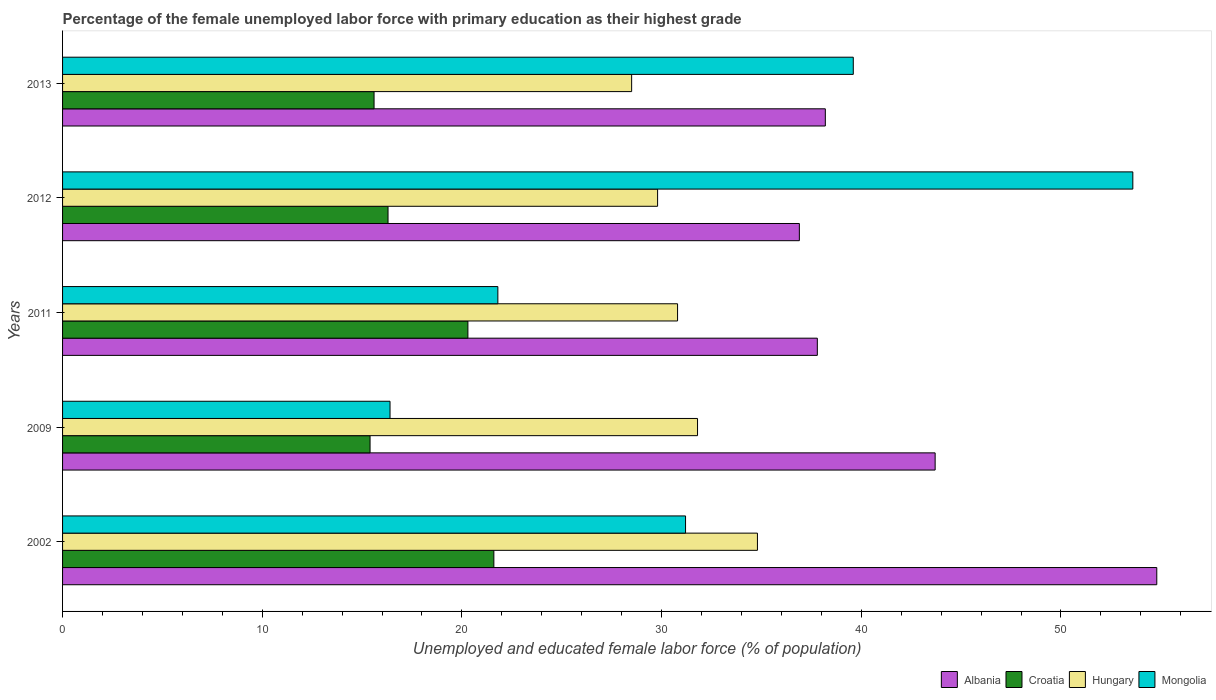How many different coloured bars are there?
Give a very brief answer. 4. Are the number of bars per tick equal to the number of legend labels?
Offer a terse response. Yes. Are the number of bars on each tick of the Y-axis equal?
Give a very brief answer. Yes. What is the percentage of the unemployed female labor force with primary education in Albania in 2013?
Offer a very short reply. 38.2. Across all years, what is the maximum percentage of the unemployed female labor force with primary education in Hungary?
Your answer should be very brief. 34.8. Across all years, what is the minimum percentage of the unemployed female labor force with primary education in Croatia?
Provide a succinct answer. 15.4. In which year was the percentage of the unemployed female labor force with primary education in Hungary maximum?
Offer a terse response. 2002. What is the total percentage of the unemployed female labor force with primary education in Croatia in the graph?
Your answer should be very brief. 89.2. What is the difference between the percentage of the unemployed female labor force with primary education in Albania in 2009 and that in 2012?
Your answer should be very brief. 6.8. What is the difference between the percentage of the unemployed female labor force with primary education in Albania in 2013 and the percentage of the unemployed female labor force with primary education in Croatia in 2012?
Ensure brevity in your answer.  21.9. What is the average percentage of the unemployed female labor force with primary education in Albania per year?
Ensure brevity in your answer.  42.28. In the year 2013, what is the difference between the percentage of the unemployed female labor force with primary education in Albania and percentage of the unemployed female labor force with primary education in Hungary?
Your response must be concise. 9.7. What is the ratio of the percentage of the unemployed female labor force with primary education in Hungary in 2011 to that in 2013?
Provide a succinct answer. 1.08. What is the difference between the highest and the second highest percentage of the unemployed female labor force with primary education in Croatia?
Offer a terse response. 1.3. What is the difference between the highest and the lowest percentage of the unemployed female labor force with primary education in Albania?
Your answer should be very brief. 17.9. What does the 4th bar from the top in 2013 represents?
Your answer should be very brief. Albania. What does the 2nd bar from the bottom in 2009 represents?
Offer a very short reply. Croatia. Is it the case that in every year, the sum of the percentage of the unemployed female labor force with primary education in Croatia and percentage of the unemployed female labor force with primary education in Mongolia is greater than the percentage of the unemployed female labor force with primary education in Hungary?
Give a very brief answer. Yes. How many bars are there?
Provide a short and direct response. 20. Are all the bars in the graph horizontal?
Your answer should be compact. Yes. How many years are there in the graph?
Provide a short and direct response. 5. Does the graph contain grids?
Provide a succinct answer. No. How many legend labels are there?
Your answer should be very brief. 4. What is the title of the graph?
Your answer should be very brief. Percentage of the female unemployed labor force with primary education as their highest grade. Does "Sierra Leone" appear as one of the legend labels in the graph?
Provide a succinct answer. No. What is the label or title of the X-axis?
Provide a short and direct response. Unemployed and educated female labor force (% of population). What is the label or title of the Y-axis?
Your response must be concise. Years. What is the Unemployed and educated female labor force (% of population) of Albania in 2002?
Provide a succinct answer. 54.8. What is the Unemployed and educated female labor force (% of population) of Croatia in 2002?
Your answer should be compact. 21.6. What is the Unemployed and educated female labor force (% of population) of Hungary in 2002?
Keep it short and to the point. 34.8. What is the Unemployed and educated female labor force (% of population) of Mongolia in 2002?
Provide a short and direct response. 31.2. What is the Unemployed and educated female labor force (% of population) of Albania in 2009?
Your response must be concise. 43.7. What is the Unemployed and educated female labor force (% of population) of Croatia in 2009?
Make the answer very short. 15.4. What is the Unemployed and educated female labor force (% of population) in Hungary in 2009?
Provide a succinct answer. 31.8. What is the Unemployed and educated female labor force (% of population) of Mongolia in 2009?
Offer a very short reply. 16.4. What is the Unemployed and educated female labor force (% of population) of Albania in 2011?
Your answer should be compact. 37.8. What is the Unemployed and educated female labor force (% of population) of Croatia in 2011?
Your answer should be compact. 20.3. What is the Unemployed and educated female labor force (% of population) in Hungary in 2011?
Your answer should be compact. 30.8. What is the Unemployed and educated female labor force (% of population) of Mongolia in 2011?
Ensure brevity in your answer.  21.8. What is the Unemployed and educated female labor force (% of population) of Albania in 2012?
Provide a short and direct response. 36.9. What is the Unemployed and educated female labor force (% of population) in Croatia in 2012?
Provide a short and direct response. 16.3. What is the Unemployed and educated female labor force (% of population) in Hungary in 2012?
Your answer should be compact. 29.8. What is the Unemployed and educated female labor force (% of population) in Mongolia in 2012?
Ensure brevity in your answer.  53.6. What is the Unemployed and educated female labor force (% of population) of Albania in 2013?
Offer a very short reply. 38.2. What is the Unemployed and educated female labor force (% of population) in Croatia in 2013?
Your answer should be very brief. 15.6. What is the Unemployed and educated female labor force (% of population) in Hungary in 2013?
Give a very brief answer. 28.5. What is the Unemployed and educated female labor force (% of population) in Mongolia in 2013?
Make the answer very short. 39.6. Across all years, what is the maximum Unemployed and educated female labor force (% of population) of Albania?
Provide a short and direct response. 54.8. Across all years, what is the maximum Unemployed and educated female labor force (% of population) of Croatia?
Offer a terse response. 21.6. Across all years, what is the maximum Unemployed and educated female labor force (% of population) in Hungary?
Your answer should be very brief. 34.8. Across all years, what is the maximum Unemployed and educated female labor force (% of population) of Mongolia?
Provide a short and direct response. 53.6. Across all years, what is the minimum Unemployed and educated female labor force (% of population) of Albania?
Offer a very short reply. 36.9. Across all years, what is the minimum Unemployed and educated female labor force (% of population) of Croatia?
Your answer should be compact. 15.4. Across all years, what is the minimum Unemployed and educated female labor force (% of population) in Hungary?
Make the answer very short. 28.5. Across all years, what is the minimum Unemployed and educated female labor force (% of population) in Mongolia?
Your answer should be very brief. 16.4. What is the total Unemployed and educated female labor force (% of population) of Albania in the graph?
Your answer should be compact. 211.4. What is the total Unemployed and educated female labor force (% of population) of Croatia in the graph?
Offer a terse response. 89.2. What is the total Unemployed and educated female labor force (% of population) in Hungary in the graph?
Your answer should be very brief. 155.7. What is the total Unemployed and educated female labor force (% of population) in Mongolia in the graph?
Offer a terse response. 162.6. What is the difference between the Unemployed and educated female labor force (% of population) in Albania in 2002 and that in 2009?
Keep it short and to the point. 11.1. What is the difference between the Unemployed and educated female labor force (% of population) in Hungary in 2002 and that in 2009?
Keep it short and to the point. 3. What is the difference between the Unemployed and educated female labor force (% of population) in Mongolia in 2002 and that in 2009?
Keep it short and to the point. 14.8. What is the difference between the Unemployed and educated female labor force (% of population) of Croatia in 2002 and that in 2011?
Offer a very short reply. 1.3. What is the difference between the Unemployed and educated female labor force (% of population) of Mongolia in 2002 and that in 2011?
Keep it short and to the point. 9.4. What is the difference between the Unemployed and educated female labor force (% of population) in Albania in 2002 and that in 2012?
Your response must be concise. 17.9. What is the difference between the Unemployed and educated female labor force (% of population) of Croatia in 2002 and that in 2012?
Make the answer very short. 5.3. What is the difference between the Unemployed and educated female labor force (% of population) of Hungary in 2002 and that in 2012?
Ensure brevity in your answer.  5. What is the difference between the Unemployed and educated female labor force (% of population) of Mongolia in 2002 and that in 2012?
Ensure brevity in your answer.  -22.4. What is the difference between the Unemployed and educated female labor force (% of population) of Hungary in 2002 and that in 2013?
Offer a very short reply. 6.3. What is the difference between the Unemployed and educated female labor force (% of population) of Mongolia in 2002 and that in 2013?
Your answer should be very brief. -8.4. What is the difference between the Unemployed and educated female labor force (% of population) of Croatia in 2009 and that in 2011?
Your answer should be very brief. -4.9. What is the difference between the Unemployed and educated female labor force (% of population) in Hungary in 2009 and that in 2011?
Provide a succinct answer. 1. What is the difference between the Unemployed and educated female labor force (% of population) of Mongolia in 2009 and that in 2011?
Your response must be concise. -5.4. What is the difference between the Unemployed and educated female labor force (% of population) in Mongolia in 2009 and that in 2012?
Your response must be concise. -37.2. What is the difference between the Unemployed and educated female labor force (% of population) of Albania in 2009 and that in 2013?
Ensure brevity in your answer.  5.5. What is the difference between the Unemployed and educated female labor force (% of population) in Croatia in 2009 and that in 2013?
Offer a terse response. -0.2. What is the difference between the Unemployed and educated female labor force (% of population) in Hungary in 2009 and that in 2013?
Keep it short and to the point. 3.3. What is the difference between the Unemployed and educated female labor force (% of population) of Mongolia in 2009 and that in 2013?
Make the answer very short. -23.2. What is the difference between the Unemployed and educated female labor force (% of population) of Croatia in 2011 and that in 2012?
Give a very brief answer. 4. What is the difference between the Unemployed and educated female labor force (% of population) in Hungary in 2011 and that in 2012?
Provide a short and direct response. 1. What is the difference between the Unemployed and educated female labor force (% of population) of Mongolia in 2011 and that in 2012?
Ensure brevity in your answer.  -31.8. What is the difference between the Unemployed and educated female labor force (% of population) of Hungary in 2011 and that in 2013?
Your answer should be very brief. 2.3. What is the difference between the Unemployed and educated female labor force (% of population) of Mongolia in 2011 and that in 2013?
Keep it short and to the point. -17.8. What is the difference between the Unemployed and educated female labor force (% of population) in Hungary in 2012 and that in 2013?
Keep it short and to the point. 1.3. What is the difference between the Unemployed and educated female labor force (% of population) of Mongolia in 2012 and that in 2013?
Keep it short and to the point. 14. What is the difference between the Unemployed and educated female labor force (% of population) in Albania in 2002 and the Unemployed and educated female labor force (% of population) in Croatia in 2009?
Offer a very short reply. 39.4. What is the difference between the Unemployed and educated female labor force (% of population) of Albania in 2002 and the Unemployed and educated female labor force (% of population) of Mongolia in 2009?
Your response must be concise. 38.4. What is the difference between the Unemployed and educated female labor force (% of population) of Croatia in 2002 and the Unemployed and educated female labor force (% of population) of Hungary in 2009?
Your response must be concise. -10.2. What is the difference between the Unemployed and educated female labor force (% of population) in Albania in 2002 and the Unemployed and educated female labor force (% of population) in Croatia in 2011?
Your answer should be compact. 34.5. What is the difference between the Unemployed and educated female labor force (% of population) in Albania in 2002 and the Unemployed and educated female labor force (% of population) in Hungary in 2011?
Make the answer very short. 24. What is the difference between the Unemployed and educated female labor force (% of population) of Croatia in 2002 and the Unemployed and educated female labor force (% of population) of Hungary in 2011?
Your answer should be compact. -9.2. What is the difference between the Unemployed and educated female labor force (% of population) of Croatia in 2002 and the Unemployed and educated female labor force (% of population) of Mongolia in 2011?
Your answer should be compact. -0.2. What is the difference between the Unemployed and educated female labor force (% of population) of Albania in 2002 and the Unemployed and educated female labor force (% of population) of Croatia in 2012?
Provide a succinct answer. 38.5. What is the difference between the Unemployed and educated female labor force (% of population) of Croatia in 2002 and the Unemployed and educated female labor force (% of population) of Hungary in 2012?
Ensure brevity in your answer.  -8.2. What is the difference between the Unemployed and educated female labor force (% of population) in Croatia in 2002 and the Unemployed and educated female labor force (% of population) in Mongolia in 2012?
Give a very brief answer. -32. What is the difference between the Unemployed and educated female labor force (% of population) in Hungary in 2002 and the Unemployed and educated female labor force (% of population) in Mongolia in 2012?
Provide a succinct answer. -18.8. What is the difference between the Unemployed and educated female labor force (% of population) in Albania in 2002 and the Unemployed and educated female labor force (% of population) in Croatia in 2013?
Your answer should be compact. 39.2. What is the difference between the Unemployed and educated female labor force (% of population) in Albania in 2002 and the Unemployed and educated female labor force (% of population) in Hungary in 2013?
Offer a very short reply. 26.3. What is the difference between the Unemployed and educated female labor force (% of population) in Albania in 2002 and the Unemployed and educated female labor force (% of population) in Mongolia in 2013?
Make the answer very short. 15.2. What is the difference between the Unemployed and educated female labor force (% of population) in Croatia in 2002 and the Unemployed and educated female labor force (% of population) in Hungary in 2013?
Give a very brief answer. -6.9. What is the difference between the Unemployed and educated female labor force (% of population) in Hungary in 2002 and the Unemployed and educated female labor force (% of population) in Mongolia in 2013?
Keep it short and to the point. -4.8. What is the difference between the Unemployed and educated female labor force (% of population) in Albania in 2009 and the Unemployed and educated female labor force (% of population) in Croatia in 2011?
Ensure brevity in your answer.  23.4. What is the difference between the Unemployed and educated female labor force (% of population) in Albania in 2009 and the Unemployed and educated female labor force (% of population) in Hungary in 2011?
Give a very brief answer. 12.9. What is the difference between the Unemployed and educated female labor force (% of population) of Albania in 2009 and the Unemployed and educated female labor force (% of population) of Mongolia in 2011?
Provide a short and direct response. 21.9. What is the difference between the Unemployed and educated female labor force (% of population) of Croatia in 2009 and the Unemployed and educated female labor force (% of population) of Hungary in 2011?
Your response must be concise. -15.4. What is the difference between the Unemployed and educated female labor force (% of population) of Croatia in 2009 and the Unemployed and educated female labor force (% of population) of Mongolia in 2011?
Provide a succinct answer. -6.4. What is the difference between the Unemployed and educated female labor force (% of population) of Albania in 2009 and the Unemployed and educated female labor force (% of population) of Croatia in 2012?
Ensure brevity in your answer.  27.4. What is the difference between the Unemployed and educated female labor force (% of population) in Croatia in 2009 and the Unemployed and educated female labor force (% of population) in Hungary in 2012?
Give a very brief answer. -14.4. What is the difference between the Unemployed and educated female labor force (% of population) in Croatia in 2009 and the Unemployed and educated female labor force (% of population) in Mongolia in 2012?
Make the answer very short. -38.2. What is the difference between the Unemployed and educated female labor force (% of population) of Hungary in 2009 and the Unemployed and educated female labor force (% of population) of Mongolia in 2012?
Ensure brevity in your answer.  -21.8. What is the difference between the Unemployed and educated female labor force (% of population) in Albania in 2009 and the Unemployed and educated female labor force (% of population) in Croatia in 2013?
Provide a short and direct response. 28.1. What is the difference between the Unemployed and educated female labor force (% of population) of Croatia in 2009 and the Unemployed and educated female labor force (% of population) of Mongolia in 2013?
Ensure brevity in your answer.  -24.2. What is the difference between the Unemployed and educated female labor force (% of population) in Albania in 2011 and the Unemployed and educated female labor force (% of population) in Croatia in 2012?
Your answer should be compact. 21.5. What is the difference between the Unemployed and educated female labor force (% of population) of Albania in 2011 and the Unemployed and educated female labor force (% of population) of Mongolia in 2012?
Give a very brief answer. -15.8. What is the difference between the Unemployed and educated female labor force (% of population) of Croatia in 2011 and the Unemployed and educated female labor force (% of population) of Mongolia in 2012?
Provide a succinct answer. -33.3. What is the difference between the Unemployed and educated female labor force (% of population) of Hungary in 2011 and the Unemployed and educated female labor force (% of population) of Mongolia in 2012?
Keep it short and to the point. -22.8. What is the difference between the Unemployed and educated female labor force (% of population) in Albania in 2011 and the Unemployed and educated female labor force (% of population) in Hungary in 2013?
Ensure brevity in your answer.  9.3. What is the difference between the Unemployed and educated female labor force (% of population) in Croatia in 2011 and the Unemployed and educated female labor force (% of population) in Mongolia in 2013?
Ensure brevity in your answer.  -19.3. What is the difference between the Unemployed and educated female labor force (% of population) of Albania in 2012 and the Unemployed and educated female labor force (% of population) of Croatia in 2013?
Ensure brevity in your answer.  21.3. What is the difference between the Unemployed and educated female labor force (% of population) of Croatia in 2012 and the Unemployed and educated female labor force (% of population) of Hungary in 2013?
Your answer should be compact. -12.2. What is the difference between the Unemployed and educated female labor force (% of population) of Croatia in 2012 and the Unemployed and educated female labor force (% of population) of Mongolia in 2013?
Give a very brief answer. -23.3. What is the difference between the Unemployed and educated female labor force (% of population) of Hungary in 2012 and the Unemployed and educated female labor force (% of population) of Mongolia in 2013?
Provide a short and direct response. -9.8. What is the average Unemployed and educated female labor force (% of population) in Albania per year?
Your answer should be compact. 42.28. What is the average Unemployed and educated female labor force (% of population) in Croatia per year?
Your response must be concise. 17.84. What is the average Unemployed and educated female labor force (% of population) of Hungary per year?
Offer a terse response. 31.14. What is the average Unemployed and educated female labor force (% of population) in Mongolia per year?
Your response must be concise. 32.52. In the year 2002, what is the difference between the Unemployed and educated female labor force (% of population) of Albania and Unemployed and educated female labor force (% of population) of Croatia?
Offer a terse response. 33.2. In the year 2002, what is the difference between the Unemployed and educated female labor force (% of population) in Albania and Unemployed and educated female labor force (% of population) in Hungary?
Your response must be concise. 20. In the year 2002, what is the difference between the Unemployed and educated female labor force (% of population) of Albania and Unemployed and educated female labor force (% of population) of Mongolia?
Your response must be concise. 23.6. In the year 2009, what is the difference between the Unemployed and educated female labor force (% of population) of Albania and Unemployed and educated female labor force (% of population) of Croatia?
Give a very brief answer. 28.3. In the year 2009, what is the difference between the Unemployed and educated female labor force (% of population) in Albania and Unemployed and educated female labor force (% of population) in Hungary?
Give a very brief answer. 11.9. In the year 2009, what is the difference between the Unemployed and educated female labor force (% of population) of Albania and Unemployed and educated female labor force (% of population) of Mongolia?
Ensure brevity in your answer.  27.3. In the year 2009, what is the difference between the Unemployed and educated female labor force (% of population) of Croatia and Unemployed and educated female labor force (% of population) of Hungary?
Your answer should be compact. -16.4. In the year 2009, what is the difference between the Unemployed and educated female labor force (% of population) of Croatia and Unemployed and educated female labor force (% of population) of Mongolia?
Provide a succinct answer. -1. In the year 2009, what is the difference between the Unemployed and educated female labor force (% of population) of Hungary and Unemployed and educated female labor force (% of population) of Mongolia?
Your answer should be very brief. 15.4. In the year 2011, what is the difference between the Unemployed and educated female labor force (% of population) in Albania and Unemployed and educated female labor force (% of population) in Croatia?
Provide a succinct answer. 17.5. In the year 2011, what is the difference between the Unemployed and educated female labor force (% of population) of Albania and Unemployed and educated female labor force (% of population) of Hungary?
Your answer should be compact. 7. In the year 2011, what is the difference between the Unemployed and educated female labor force (% of population) in Croatia and Unemployed and educated female labor force (% of population) in Hungary?
Provide a short and direct response. -10.5. In the year 2011, what is the difference between the Unemployed and educated female labor force (% of population) of Croatia and Unemployed and educated female labor force (% of population) of Mongolia?
Your answer should be compact. -1.5. In the year 2011, what is the difference between the Unemployed and educated female labor force (% of population) in Hungary and Unemployed and educated female labor force (% of population) in Mongolia?
Your response must be concise. 9. In the year 2012, what is the difference between the Unemployed and educated female labor force (% of population) of Albania and Unemployed and educated female labor force (% of population) of Croatia?
Ensure brevity in your answer.  20.6. In the year 2012, what is the difference between the Unemployed and educated female labor force (% of population) of Albania and Unemployed and educated female labor force (% of population) of Hungary?
Make the answer very short. 7.1. In the year 2012, what is the difference between the Unemployed and educated female labor force (% of population) of Albania and Unemployed and educated female labor force (% of population) of Mongolia?
Your response must be concise. -16.7. In the year 2012, what is the difference between the Unemployed and educated female labor force (% of population) in Croatia and Unemployed and educated female labor force (% of population) in Hungary?
Your response must be concise. -13.5. In the year 2012, what is the difference between the Unemployed and educated female labor force (% of population) of Croatia and Unemployed and educated female labor force (% of population) of Mongolia?
Keep it short and to the point. -37.3. In the year 2012, what is the difference between the Unemployed and educated female labor force (% of population) in Hungary and Unemployed and educated female labor force (% of population) in Mongolia?
Provide a short and direct response. -23.8. In the year 2013, what is the difference between the Unemployed and educated female labor force (% of population) in Albania and Unemployed and educated female labor force (% of population) in Croatia?
Offer a terse response. 22.6. In the year 2013, what is the difference between the Unemployed and educated female labor force (% of population) of Croatia and Unemployed and educated female labor force (% of population) of Hungary?
Ensure brevity in your answer.  -12.9. What is the ratio of the Unemployed and educated female labor force (% of population) of Albania in 2002 to that in 2009?
Keep it short and to the point. 1.25. What is the ratio of the Unemployed and educated female labor force (% of population) in Croatia in 2002 to that in 2009?
Offer a very short reply. 1.4. What is the ratio of the Unemployed and educated female labor force (% of population) of Hungary in 2002 to that in 2009?
Ensure brevity in your answer.  1.09. What is the ratio of the Unemployed and educated female labor force (% of population) of Mongolia in 2002 to that in 2009?
Offer a very short reply. 1.9. What is the ratio of the Unemployed and educated female labor force (% of population) of Albania in 2002 to that in 2011?
Ensure brevity in your answer.  1.45. What is the ratio of the Unemployed and educated female labor force (% of population) of Croatia in 2002 to that in 2011?
Ensure brevity in your answer.  1.06. What is the ratio of the Unemployed and educated female labor force (% of population) in Hungary in 2002 to that in 2011?
Provide a succinct answer. 1.13. What is the ratio of the Unemployed and educated female labor force (% of population) of Mongolia in 2002 to that in 2011?
Keep it short and to the point. 1.43. What is the ratio of the Unemployed and educated female labor force (% of population) in Albania in 2002 to that in 2012?
Keep it short and to the point. 1.49. What is the ratio of the Unemployed and educated female labor force (% of population) in Croatia in 2002 to that in 2012?
Offer a very short reply. 1.33. What is the ratio of the Unemployed and educated female labor force (% of population) in Hungary in 2002 to that in 2012?
Your answer should be compact. 1.17. What is the ratio of the Unemployed and educated female labor force (% of population) of Mongolia in 2002 to that in 2012?
Keep it short and to the point. 0.58. What is the ratio of the Unemployed and educated female labor force (% of population) of Albania in 2002 to that in 2013?
Give a very brief answer. 1.43. What is the ratio of the Unemployed and educated female labor force (% of population) of Croatia in 2002 to that in 2013?
Your answer should be compact. 1.38. What is the ratio of the Unemployed and educated female labor force (% of population) in Hungary in 2002 to that in 2013?
Give a very brief answer. 1.22. What is the ratio of the Unemployed and educated female labor force (% of population) in Mongolia in 2002 to that in 2013?
Your answer should be compact. 0.79. What is the ratio of the Unemployed and educated female labor force (% of population) in Albania in 2009 to that in 2011?
Provide a short and direct response. 1.16. What is the ratio of the Unemployed and educated female labor force (% of population) of Croatia in 2009 to that in 2011?
Keep it short and to the point. 0.76. What is the ratio of the Unemployed and educated female labor force (% of population) of Hungary in 2009 to that in 2011?
Your response must be concise. 1.03. What is the ratio of the Unemployed and educated female labor force (% of population) of Mongolia in 2009 to that in 2011?
Provide a succinct answer. 0.75. What is the ratio of the Unemployed and educated female labor force (% of population) of Albania in 2009 to that in 2012?
Provide a short and direct response. 1.18. What is the ratio of the Unemployed and educated female labor force (% of population) in Croatia in 2009 to that in 2012?
Keep it short and to the point. 0.94. What is the ratio of the Unemployed and educated female labor force (% of population) in Hungary in 2009 to that in 2012?
Your response must be concise. 1.07. What is the ratio of the Unemployed and educated female labor force (% of population) of Mongolia in 2009 to that in 2012?
Provide a succinct answer. 0.31. What is the ratio of the Unemployed and educated female labor force (% of population) of Albania in 2009 to that in 2013?
Offer a very short reply. 1.14. What is the ratio of the Unemployed and educated female labor force (% of population) in Croatia in 2009 to that in 2013?
Your answer should be compact. 0.99. What is the ratio of the Unemployed and educated female labor force (% of population) in Hungary in 2009 to that in 2013?
Your answer should be very brief. 1.12. What is the ratio of the Unemployed and educated female labor force (% of population) in Mongolia in 2009 to that in 2013?
Give a very brief answer. 0.41. What is the ratio of the Unemployed and educated female labor force (% of population) of Albania in 2011 to that in 2012?
Offer a terse response. 1.02. What is the ratio of the Unemployed and educated female labor force (% of population) in Croatia in 2011 to that in 2012?
Provide a succinct answer. 1.25. What is the ratio of the Unemployed and educated female labor force (% of population) of Hungary in 2011 to that in 2012?
Your answer should be compact. 1.03. What is the ratio of the Unemployed and educated female labor force (% of population) in Mongolia in 2011 to that in 2012?
Your answer should be very brief. 0.41. What is the ratio of the Unemployed and educated female labor force (% of population) of Croatia in 2011 to that in 2013?
Ensure brevity in your answer.  1.3. What is the ratio of the Unemployed and educated female labor force (% of population) of Hungary in 2011 to that in 2013?
Your response must be concise. 1.08. What is the ratio of the Unemployed and educated female labor force (% of population) of Mongolia in 2011 to that in 2013?
Provide a short and direct response. 0.55. What is the ratio of the Unemployed and educated female labor force (% of population) in Croatia in 2012 to that in 2013?
Give a very brief answer. 1.04. What is the ratio of the Unemployed and educated female labor force (% of population) in Hungary in 2012 to that in 2013?
Your answer should be very brief. 1.05. What is the ratio of the Unemployed and educated female labor force (% of population) of Mongolia in 2012 to that in 2013?
Provide a short and direct response. 1.35. What is the difference between the highest and the second highest Unemployed and educated female labor force (% of population) of Mongolia?
Make the answer very short. 14. What is the difference between the highest and the lowest Unemployed and educated female labor force (% of population) in Albania?
Your response must be concise. 17.9. What is the difference between the highest and the lowest Unemployed and educated female labor force (% of population) in Croatia?
Offer a terse response. 6.2. What is the difference between the highest and the lowest Unemployed and educated female labor force (% of population) of Mongolia?
Provide a short and direct response. 37.2. 